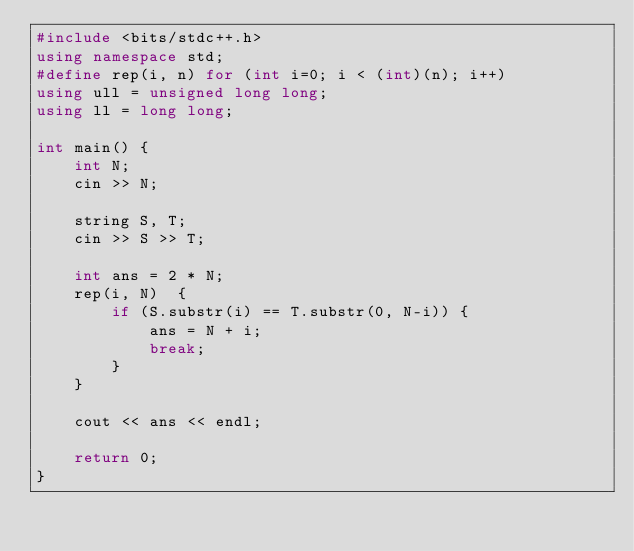Convert code to text. <code><loc_0><loc_0><loc_500><loc_500><_C++_>#include <bits/stdc++.h>
using namespace std;
#define rep(i, n) for (int i=0; i < (int)(n); i++)
using ull = unsigned long long;
using ll = long long;

int main() {
    int N;
    cin >> N;

    string S, T;
    cin >> S >> T;

    int ans = 2 * N;
    rep(i, N)  {
        if (S.substr(i) == T.substr(0, N-i)) {
            ans = N + i;
            break;
        }
    }

    cout << ans << endl;

    return 0;
}</code> 